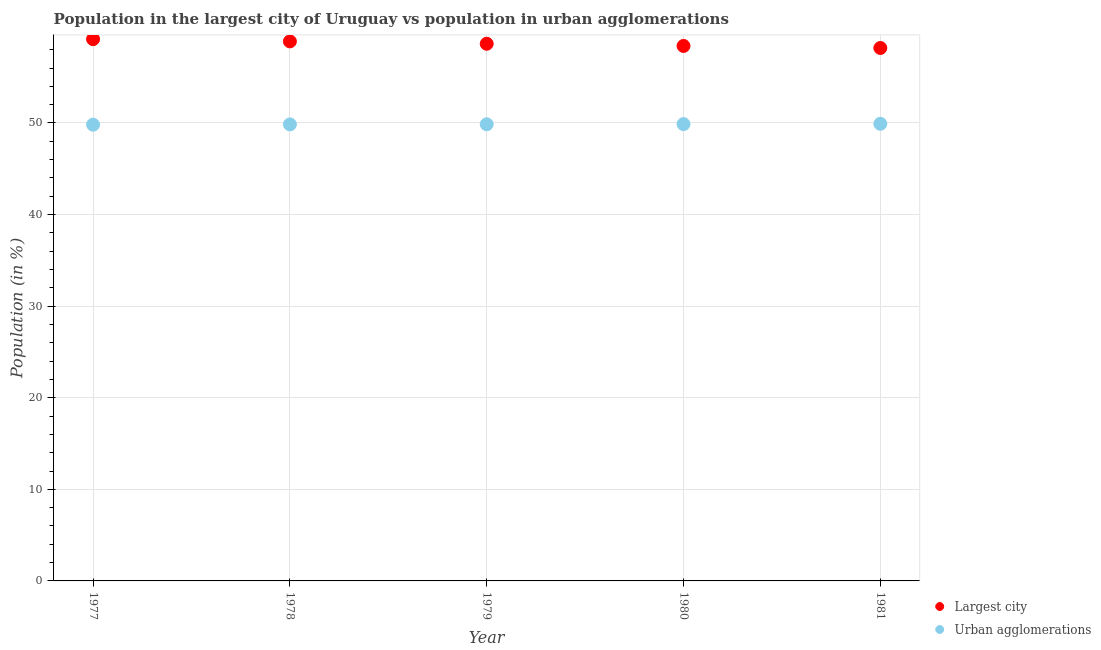What is the population in urban agglomerations in 1980?
Keep it short and to the point. 49.88. Across all years, what is the maximum population in urban agglomerations?
Offer a terse response. 49.91. Across all years, what is the minimum population in urban agglomerations?
Your answer should be very brief. 49.81. What is the total population in the largest city in the graph?
Provide a short and direct response. 293.3. What is the difference between the population in urban agglomerations in 1978 and that in 1979?
Your answer should be compact. -0.01. What is the difference between the population in the largest city in 1979 and the population in urban agglomerations in 1977?
Offer a terse response. 8.83. What is the average population in the largest city per year?
Your answer should be very brief. 58.66. In the year 1981, what is the difference between the population in the largest city and population in urban agglomerations?
Your answer should be very brief. 8.28. What is the ratio of the population in urban agglomerations in 1977 to that in 1978?
Provide a short and direct response. 1. Is the population in urban agglomerations in 1977 less than that in 1981?
Offer a very short reply. Yes. What is the difference between the highest and the second highest population in urban agglomerations?
Provide a succinct answer. 0.03. What is the difference between the highest and the lowest population in urban agglomerations?
Your answer should be compact. 0.09. Is the sum of the population in urban agglomerations in 1978 and 1980 greater than the maximum population in the largest city across all years?
Offer a very short reply. Yes. Does the population in urban agglomerations monotonically increase over the years?
Give a very brief answer. Yes. Is the population in urban agglomerations strictly less than the population in the largest city over the years?
Give a very brief answer. Yes. How many dotlines are there?
Offer a very short reply. 2. Does the graph contain grids?
Offer a very short reply. Yes. Where does the legend appear in the graph?
Offer a terse response. Bottom right. How many legend labels are there?
Your answer should be very brief. 2. How are the legend labels stacked?
Provide a short and direct response. Vertical. What is the title of the graph?
Provide a succinct answer. Population in the largest city of Uruguay vs population in urban agglomerations. What is the label or title of the X-axis?
Provide a succinct answer. Year. What is the label or title of the Y-axis?
Give a very brief answer. Population (in %). What is the Population (in %) of Largest city in 1977?
Make the answer very short. 59.15. What is the Population (in %) of Urban agglomerations in 1977?
Provide a succinct answer. 49.81. What is the Population (in %) in Largest city in 1978?
Provide a succinct answer. 58.91. What is the Population (in %) in Urban agglomerations in 1978?
Offer a very short reply. 49.84. What is the Population (in %) of Largest city in 1979?
Make the answer very short. 58.65. What is the Population (in %) of Urban agglomerations in 1979?
Offer a very short reply. 49.86. What is the Population (in %) of Largest city in 1980?
Offer a very short reply. 58.41. What is the Population (in %) in Urban agglomerations in 1980?
Offer a very short reply. 49.88. What is the Population (in %) in Largest city in 1981?
Ensure brevity in your answer.  58.19. What is the Population (in %) of Urban agglomerations in 1981?
Provide a short and direct response. 49.91. Across all years, what is the maximum Population (in %) in Largest city?
Offer a terse response. 59.15. Across all years, what is the maximum Population (in %) of Urban agglomerations?
Provide a short and direct response. 49.91. Across all years, what is the minimum Population (in %) of Largest city?
Offer a very short reply. 58.19. Across all years, what is the minimum Population (in %) in Urban agglomerations?
Your answer should be very brief. 49.81. What is the total Population (in %) of Largest city in the graph?
Your response must be concise. 293.3. What is the total Population (in %) in Urban agglomerations in the graph?
Your answer should be compact. 249.3. What is the difference between the Population (in %) of Largest city in 1977 and that in 1978?
Provide a short and direct response. 0.24. What is the difference between the Population (in %) in Urban agglomerations in 1977 and that in 1978?
Your answer should be compact. -0.03. What is the difference between the Population (in %) in Largest city in 1977 and that in 1979?
Provide a succinct answer. 0.5. What is the difference between the Population (in %) in Urban agglomerations in 1977 and that in 1979?
Your response must be concise. -0.04. What is the difference between the Population (in %) of Largest city in 1977 and that in 1980?
Provide a short and direct response. 0.74. What is the difference between the Population (in %) in Urban agglomerations in 1977 and that in 1980?
Your answer should be compact. -0.06. What is the difference between the Population (in %) of Largest city in 1977 and that in 1981?
Your answer should be very brief. 0.96. What is the difference between the Population (in %) of Urban agglomerations in 1977 and that in 1981?
Provide a succinct answer. -0.09. What is the difference between the Population (in %) in Largest city in 1978 and that in 1979?
Offer a very short reply. 0.26. What is the difference between the Population (in %) of Urban agglomerations in 1978 and that in 1979?
Provide a succinct answer. -0.01. What is the difference between the Population (in %) of Largest city in 1978 and that in 1980?
Make the answer very short. 0.5. What is the difference between the Population (in %) of Urban agglomerations in 1978 and that in 1980?
Keep it short and to the point. -0.03. What is the difference between the Population (in %) of Largest city in 1978 and that in 1981?
Give a very brief answer. 0.72. What is the difference between the Population (in %) in Urban agglomerations in 1978 and that in 1981?
Offer a terse response. -0.06. What is the difference between the Population (in %) of Largest city in 1979 and that in 1980?
Your answer should be compact. 0.24. What is the difference between the Population (in %) in Urban agglomerations in 1979 and that in 1980?
Make the answer very short. -0.02. What is the difference between the Population (in %) in Largest city in 1979 and that in 1981?
Provide a short and direct response. 0.46. What is the difference between the Population (in %) in Largest city in 1980 and that in 1981?
Your answer should be very brief. 0.22. What is the difference between the Population (in %) of Urban agglomerations in 1980 and that in 1981?
Your answer should be very brief. -0.03. What is the difference between the Population (in %) of Largest city in 1977 and the Population (in %) of Urban agglomerations in 1978?
Your answer should be compact. 9.31. What is the difference between the Population (in %) in Largest city in 1977 and the Population (in %) in Urban agglomerations in 1979?
Keep it short and to the point. 9.29. What is the difference between the Population (in %) in Largest city in 1977 and the Population (in %) in Urban agglomerations in 1980?
Give a very brief answer. 9.27. What is the difference between the Population (in %) of Largest city in 1977 and the Population (in %) of Urban agglomerations in 1981?
Make the answer very short. 9.24. What is the difference between the Population (in %) in Largest city in 1978 and the Population (in %) in Urban agglomerations in 1979?
Your answer should be compact. 9.05. What is the difference between the Population (in %) of Largest city in 1978 and the Population (in %) of Urban agglomerations in 1980?
Offer a very short reply. 9.03. What is the difference between the Population (in %) of Largest city in 1978 and the Population (in %) of Urban agglomerations in 1981?
Make the answer very short. 9. What is the difference between the Population (in %) in Largest city in 1979 and the Population (in %) in Urban agglomerations in 1980?
Keep it short and to the point. 8.77. What is the difference between the Population (in %) of Largest city in 1979 and the Population (in %) of Urban agglomerations in 1981?
Provide a succinct answer. 8.74. What is the difference between the Population (in %) in Largest city in 1980 and the Population (in %) in Urban agglomerations in 1981?
Your answer should be compact. 8.5. What is the average Population (in %) of Largest city per year?
Keep it short and to the point. 58.66. What is the average Population (in %) of Urban agglomerations per year?
Your response must be concise. 49.86. In the year 1977, what is the difference between the Population (in %) in Largest city and Population (in %) in Urban agglomerations?
Your response must be concise. 9.34. In the year 1978, what is the difference between the Population (in %) of Largest city and Population (in %) of Urban agglomerations?
Offer a terse response. 9.06. In the year 1979, what is the difference between the Population (in %) of Largest city and Population (in %) of Urban agglomerations?
Provide a short and direct response. 8.79. In the year 1980, what is the difference between the Population (in %) of Largest city and Population (in %) of Urban agglomerations?
Your answer should be compact. 8.53. In the year 1981, what is the difference between the Population (in %) of Largest city and Population (in %) of Urban agglomerations?
Your answer should be very brief. 8.28. What is the ratio of the Population (in %) in Urban agglomerations in 1977 to that in 1978?
Give a very brief answer. 1. What is the ratio of the Population (in %) of Largest city in 1977 to that in 1979?
Provide a short and direct response. 1.01. What is the ratio of the Population (in %) of Largest city in 1977 to that in 1980?
Ensure brevity in your answer.  1.01. What is the ratio of the Population (in %) of Urban agglomerations in 1977 to that in 1980?
Your answer should be compact. 1. What is the ratio of the Population (in %) in Largest city in 1977 to that in 1981?
Your answer should be compact. 1.02. What is the ratio of the Population (in %) in Largest city in 1978 to that in 1980?
Offer a very short reply. 1.01. What is the ratio of the Population (in %) of Largest city in 1978 to that in 1981?
Make the answer very short. 1.01. What is the ratio of the Population (in %) of Largest city in 1979 to that in 1980?
Ensure brevity in your answer.  1. What is the ratio of the Population (in %) of Largest city in 1979 to that in 1981?
Offer a terse response. 1.01. What is the ratio of the Population (in %) in Urban agglomerations in 1979 to that in 1981?
Provide a succinct answer. 1. What is the ratio of the Population (in %) in Largest city in 1980 to that in 1981?
Provide a short and direct response. 1. What is the difference between the highest and the second highest Population (in %) in Largest city?
Provide a succinct answer. 0.24. What is the difference between the highest and the second highest Population (in %) of Urban agglomerations?
Offer a very short reply. 0.03. What is the difference between the highest and the lowest Population (in %) in Largest city?
Your response must be concise. 0.96. What is the difference between the highest and the lowest Population (in %) in Urban agglomerations?
Ensure brevity in your answer.  0.09. 